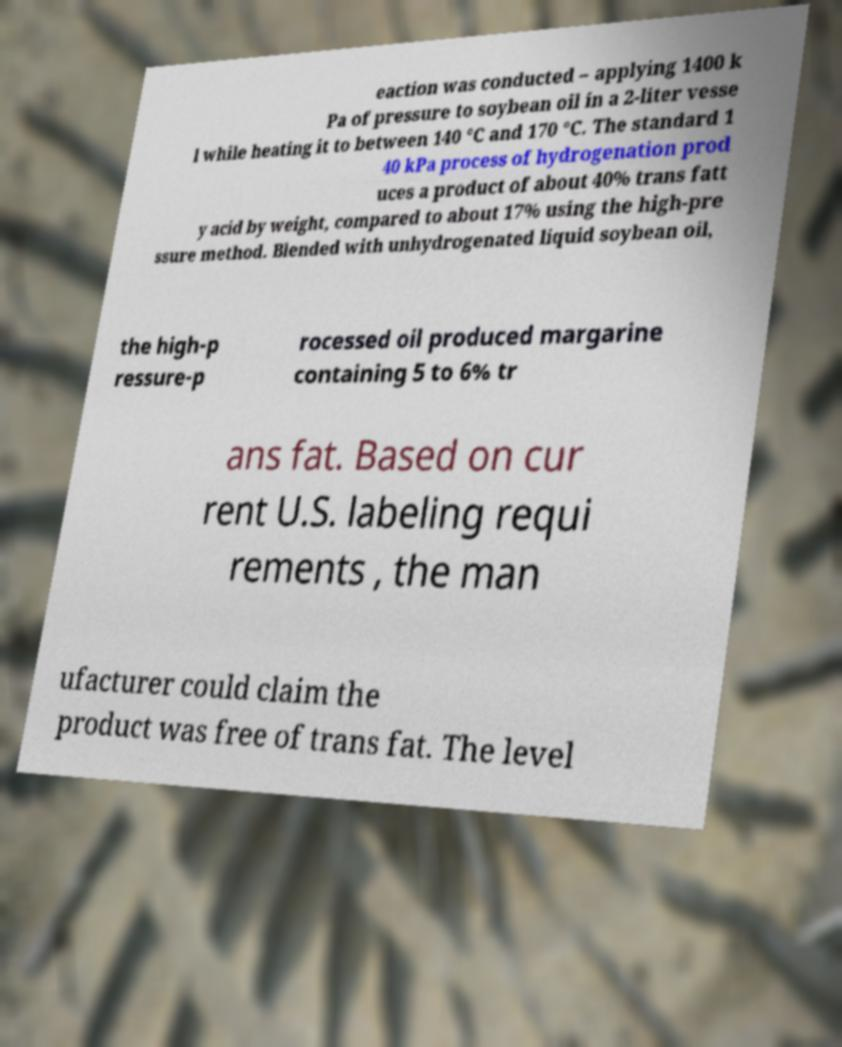Could you extract and type out the text from this image? eaction was conducted – applying 1400 k Pa of pressure to soybean oil in a 2-liter vesse l while heating it to between 140 °C and 170 °C. The standard 1 40 kPa process of hydrogenation prod uces a product of about 40% trans fatt y acid by weight, compared to about 17% using the high-pre ssure method. Blended with unhydrogenated liquid soybean oil, the high-p ressure-p rocessed oil produced margarine containing 5 to 6% tr ans fat. Based on cur rent U.S. labeling requi rements , the man ufacturer could claim the product was free of trans fat. The level 